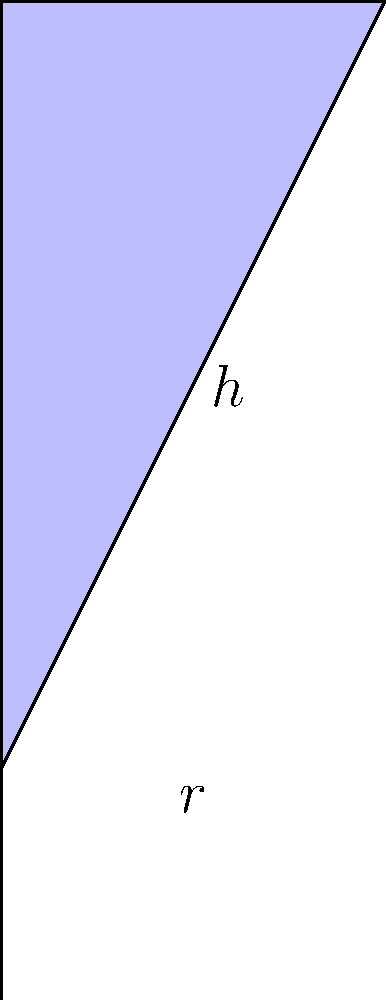In a scene from "Casino Royale" (2006), James Bond orders his iconic "shaken, not stirred" martini. The bartender uses a uniquely shaped martini glass that resembles a cone without its bottom third. If the full height of a standard conical martini glass is 15 cm and its rim radius is 7.5 cm, what fraction of a standard cone's volume does Bond's martini glass hold? Let's approach this step-by-step:

1) First, we need to calculate the volume of a standard conical martini glass:
   $$V_{cone} = \frac{1}{3}\pi r^2 h$$
   Where $r = 7.5$ cm and $h = 15$ cm
   $$V_{cone} = \frac{1}{3}\pi (7.5^2)(15) = 353.4$ cm³

2) Now, Bond's glass is missing the bottom third. To calculate this, we need to find the volume of a smaller cone that's been removed:
   - The height of this smaller cone is 1/3 of the total height: 5 cm
   - The radius of this smaller cone is 1/3 of the total radius: 2.5 cm

3) Volume of the smaller cone:
   $$V_{small} = \frac{1}{3}\pi (2.5^2)(5) = 13.1$ cm³

4) The volume of Bond's martini glass is the difference:
   $$V_{Bond} = V_{cone} - V_{small} = 353.4 - 13.1 = 340.3$ cm³

5) To express this as a fraction of the standard cone's volume:
   $$\frac{V_{Bond}}{V_{cone}} = \frac{340.3}{353.4} = 0.963$$

6) This can be simplified to $\frac{963}{1000}$ or $\frac{321}{333}$
Answer: $\frac{963}{1000}$ or $\frac{321}{333}$ 